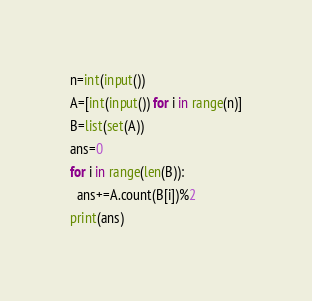<code> <loc_0><loc_0><loc_500><loc_500><_Python_>n=int(input())
A=[int(input()) for i in range(n)]
B=list(set(A))
ans=0
for i in range(len(B)):
  ans+=A.count(B[i])%2
print(ans)</code> 